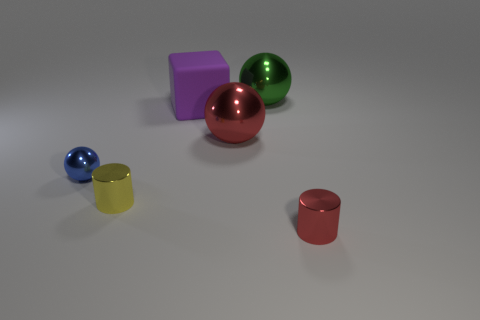Add 1 purple cubes. How many objects exist? 7 Subtract 0 brown blocks. How many objects are left? 6 Subtract all cubes. How many objects are left? 5 Subtract all small cyan objects. Subtract all big spheres. How many objects are left? 4 Add 2 yellow metallic cylinders. How many yellow metallic cylinders are left? 3 Add 5 small yellow things. How many small yellow things exist? 6 